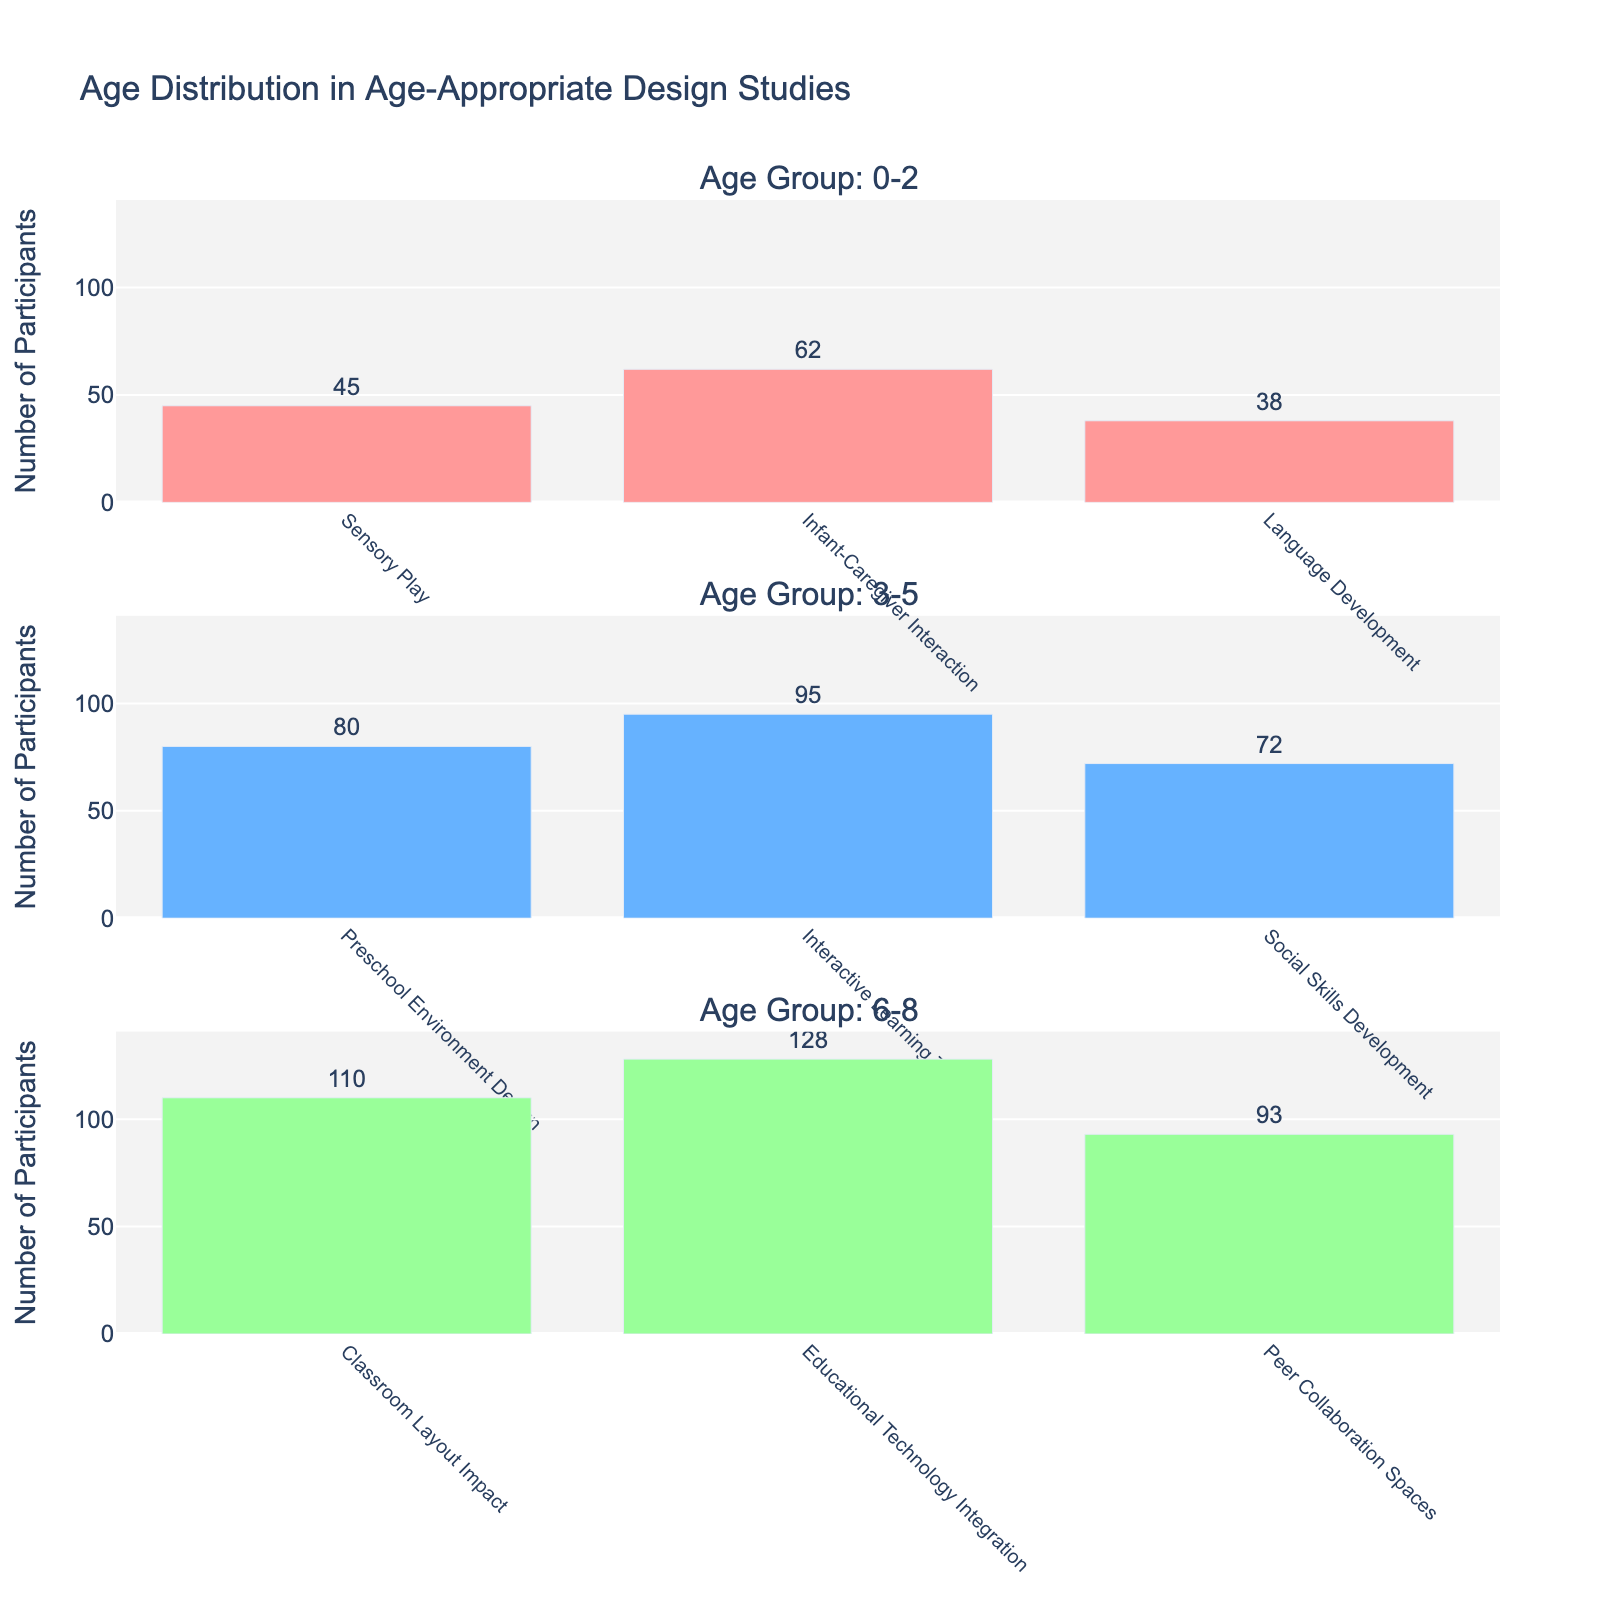Who participated the most in the '0-2' age group studies? By examining the bar heights of the '0-2' age group, the 'Infant-Caregiver Interaction' study type has the highest participant count.
Answer: Infant-Caregiver Interaction Which '3-5' age group study had the second highest number of participants? In the '3-5' age group, the highest participant count is for 'Interactive Learning Tools' (95 participants), followed by 'Preschool Environment Design' (80 participants).
Answer: Preschool Environment Design How many participants are there in total for the '6-8' age group? Adding up the number of participants across all study types in the '6-8' age group results in 110 + 128 + 93 = 331.
Answer: 331 Which age group had the most participants in the 'Social Skills Development' study type? Only the '3-5' age group has the 'Social Skills Development' study type, making it the category with the most participants for this specific study type without comparing across different age groups.
Answer: 3-5 How does the number of participants in 'Interactive Learning Tools' compare between '3-5' and '6-8' age groups? 'Interactive Learning Tools' study type is only in the '3-5' age group with 95 participants, while it doesn't exist in the '6-8' age group.
Answer: Only in 3-5 What is the difference in participants between the 'Language Development' study in the '0-2' group and the 'Peer Collaboration Spaces' study in the '6-8' group? The 'Language Development' study in the '0-2' age group has 38 participants, and the 'Peer Collaboration Spaces' study in the '6-8' age group has 93 participants. The difference is 93 - 38 = 55.
Answer: 55 What is the average number of participants in studies for the '6-8' age group? The total number of participants in the '6-8' age group is 331, and there are 3 studies. Thus, the average is 331 / 3 ≈ 110.33.
Answer: 110.33 Which study type has the least participants in the '0-2' age group? In the '0-2' age group, the 'Language Development' study type has the least participants with 38 participants.
Answer: Language Development 